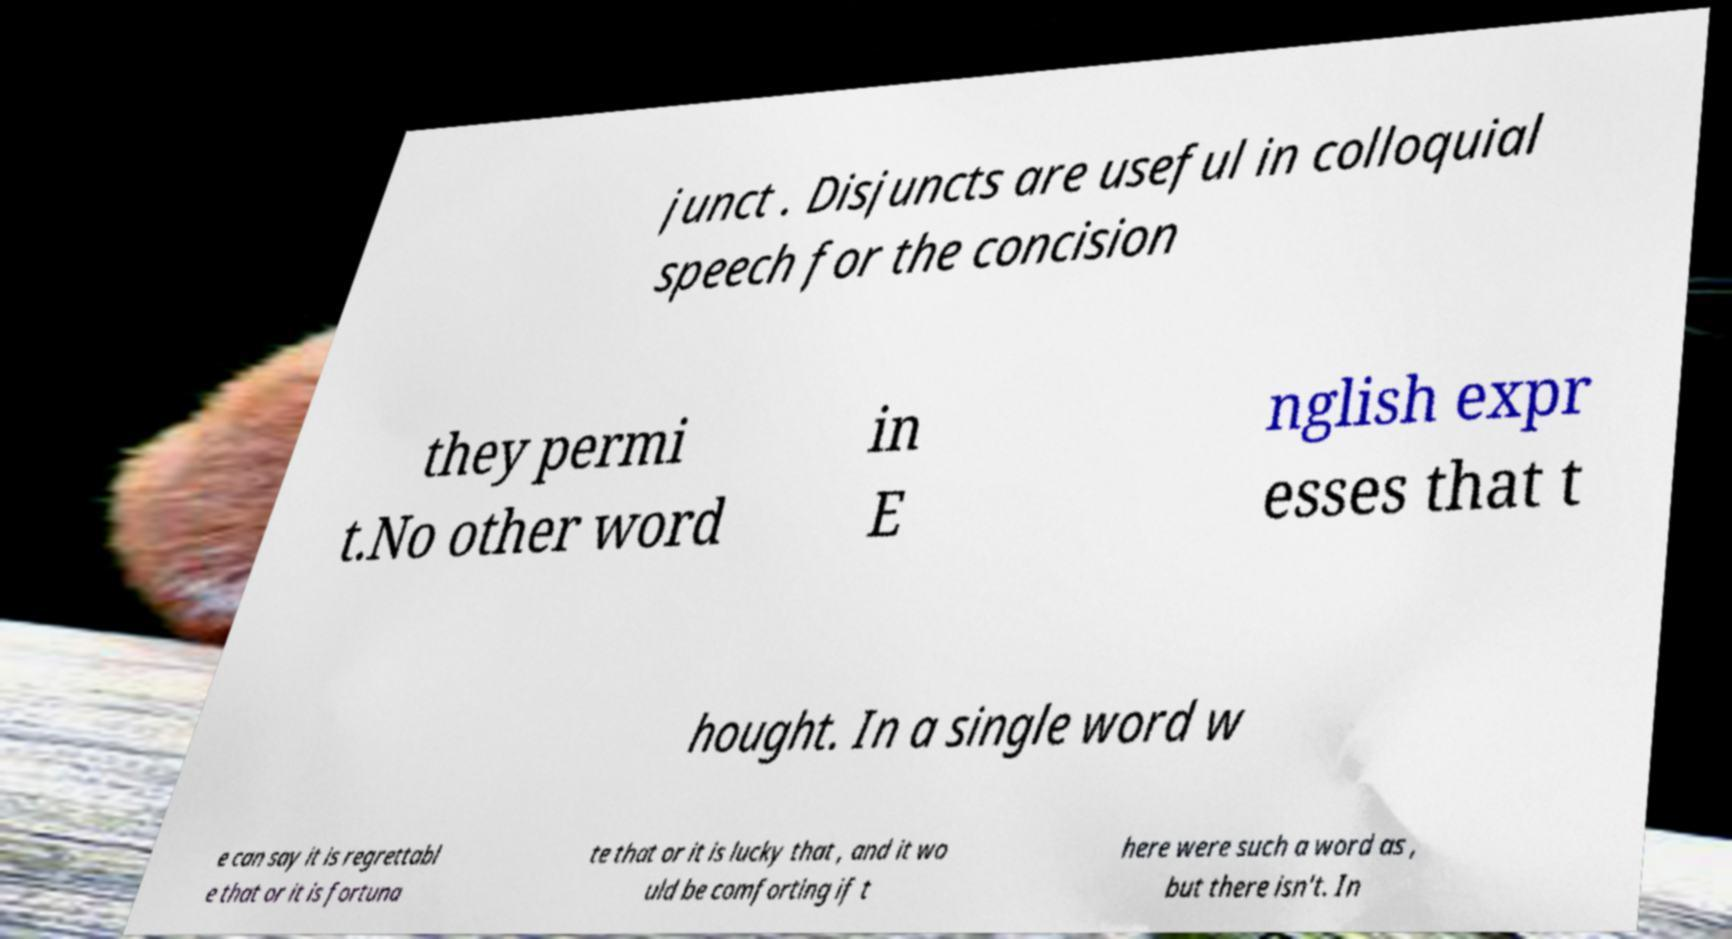Could you extract and type out the text from this image? junct . Disjuncts are useful in colloquial speech for the concision they permi t.No other word in E nglish expr esses that t hought. In a single word w e can say it is regrettabl e that or it is fortuna te that or it is lucky that , and it wo uld be comforting if t here were such a word as , but there isn't. In 